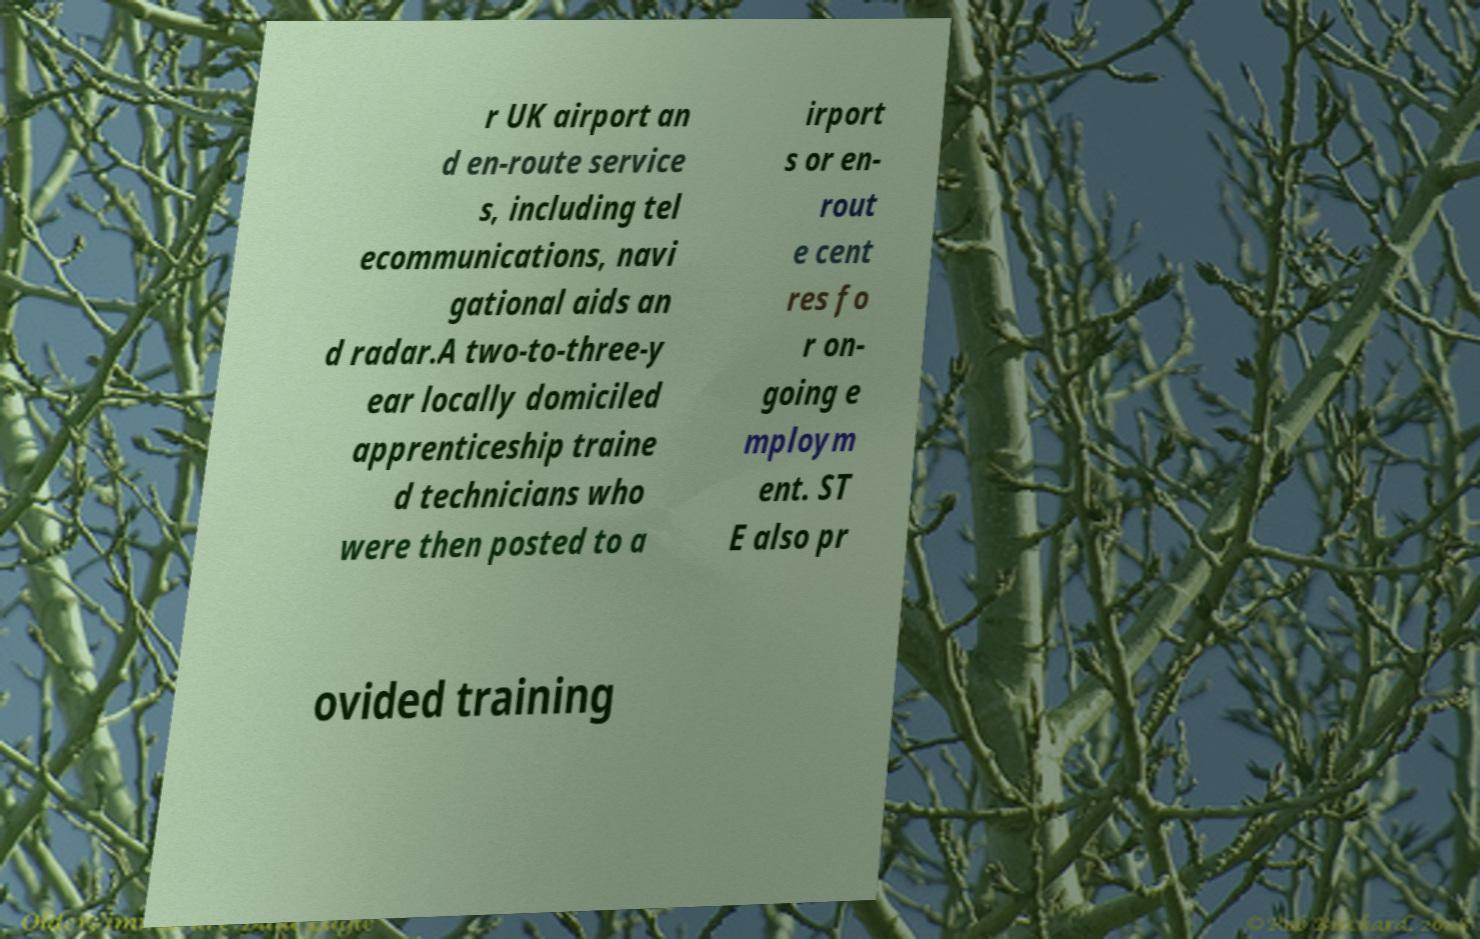What messages or text are displayed in this image? I need them in a readable, typed format. r UK airport an d en-route service s, including tel ecommunications, navi gational aids an d radar.A two-to-three-y ear locally domiciled apprenticeship traine d technicians who were then posted to a irport s or en- rout e cent res fo r on- going e mploym ent. ST E also pr ovided training 